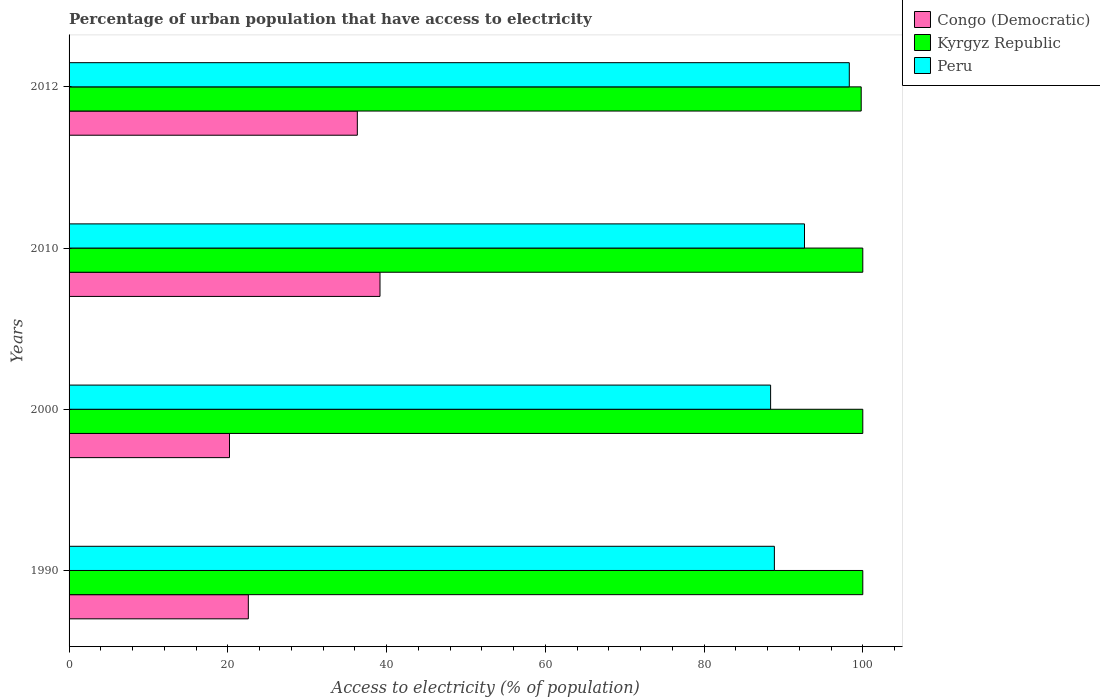How many different coloured bars are there?
Offer a terse response. 3. How many groups of bars are there?
Make the answer very short. 4. How many bars are there on the 4th tick from the top?
Offer a very short reply. 3. What is the label of the 1st group of bars from the top?
Offer a very short reply. 2012. What is the percentage of urban population that have access to electricity in Congo (Democratic) in 2010?
Offer a very short reply. 39.17. Across all years, what is the maximum percentage of urban population that have access to electricity in Congo (Democratic)?
Give a very brief answer. 39.17. Across all years, what is the minimum percentage of urban population that have access to electricity in Congo (Democratic)?
Provide a succinct answer. 20.21. In which year was the percentage of urban population that have access to electricity in Congo (Democratic) maximum?
Give a very brief answer. 2010. What is the total percentage of urban population that have access to electricity in Congo (Democratic) in the graph?
Ensure brevity in your answer.  118.29. What is the difference between the percentage of urban population that have access to electricity in Congo (Democratic) in 1990 and that in 2010?
Provide a succinct answer. -16.59. What is the difference between the percentage of urban population that have access to electricity in Congo (Democratic) in 2000 and the percentage of urban population that have access to electricity in Peru in 2012?
Your response must be concise. -78.09. What is the average percentage of urban population that have access to electricity in Congo (Democratic) per year?
Ensure brevity in your answer.  29.57. In the year 2012, what is the difference between the percentage of urban population that have access to electricity in Peru and percentage of urban population that have access to electricity in Congo (Democratic)?
Your answer should be very brief. 61.98. What is the ratio of the percentage of urban population that have access to electricity in Peru in 1990 to that in 2000?
Provide a short and direct response. 1.01. Is the difference between the percentage of urban population that have access to electricity in Peru in 2010 and 2012 greater than the difference between the percentage of urban population that have access to electricity in Congo (Democratic) in 2010 and 2012?
Your answer should be compact. No. What is the difference between the highest and the lowest percentage of urban population that have access to electricity in Kyrgyz Republic?
Your response must be concise. 0.2. Is the sum of the percentage of urban population that have access to electricity in Congo (Democratic) in 1990 and 2012 greater than the maximum percentage of urban population that have access to electricity in Kyrgyz Republic across all years?
Your response must be concise. No. What does the 1st bar from the top in 2010 represents?
Provide a short and direct response. Peru. What does the 1st bar from the bottom in 2010 represents?
Keep it short and to the point. Congo (Democratic). Is it the case that in every year, the sum of the percentage of urban population that have access to electricity in Peru and percentage of urban population that have access to electricity in Congo (Democratic) is greater than the percentage of urban population that have access to electricity in Kyrgyz Republic?
Offer a very short reply. Yes. Are all the bars in the graph horizontal?
Give a very brief answer. Yes. How many years are there in the graph?
Make the answer very short. 4. What is the difference between two consecutive major ticks on the X-axis?
Keep it short and to the point. 20. Does the graph contain any zero values?
Offer a terse response. No. Does the graph contain grids?
Give a very brief answer. No. Where does the legend appear in the graph?
Give a very brief answer. Top right. How many legend labels are there?
Ensure brevity in your answer.  3. How are the legend labels stacked?
Provide a short and direct response. Vertical. What is the title of the graph?
Keep it short and to the point. Percentage of urban population that have access to electricity. Does "Liechtenstein" appear as one of the legend labels in the graph?
Keep it short and to the point. No. What is the label or title of the X-axis?
Your response must be concise. Access to electricity (% of population). What is the Access to electricity (% of population) in Congo (Democratic) in 1990?
Your answer should be compact. 22.58. What is the Access to electricity (% of population) of Peru in 1990?
Give a very brief answer. 88.86. What is the Access to electricity (% of population) of Congo (Democratic) in 2000?
Keep it short and to the point. 20.21. What is the Access to electricity (% of population) in Peru in 2000?
Offer a terse response. 88.39. What is the Access to electricity (% of population) in Congo (Democratic) in 2010?
Your answer should be very brief. 39.17. What is the Access to electricity (% of population) in Peru in 2010?
Keep it short and to the point. 92.66. What is the Access to electricity (% of population) of Congo (Democratic) in 2012?
Ensure brevity in your answer.  36.32. What is the Access to electricity (% of population) of Kyrgyz Republic in 2012?
Make the answer very short. 99.8. What is the Access to electricity (% of population) in Peru in 2012?
Your answer should be compact. 98.3. Across all years, what is the maximum Access to electricity (% of population) of Congo (Democratic)?
Keep it short and to the point. 39.17. Across all years, what is the maximum Access to electricity (% of population) in Kyrgyz Republic?
Keep it short and to the point. 100. Across all years, what is the maximum Access to electricity (% of population) of Peru?
Offer a very short reply. 98.3. Across all years, what is the minimum Access to electricity (% of population) of Congo (Democratic)?
Offer a very short reply. 20.21. Across all years, what is the minimum Access to electricity (% of population) in Kyrgyz Republic?
Offer a terse response. 99.8. Across all years, what is the minimum Access to electricity (% of population) of Peru?
Give a very brief answer. 88.39. What is the total Access to electricity (% of population) of Congo (Democratic) in the graph?
Offer a terse response. 118.29. What is the total Access to electricity (% of population) in Kyrgyz Republic in the graph?
Give a very brief answer. 399.8. What is the total Access to electricity (% of population) in Peru in the graph?
Offer a very short reply. 368.2. What is the difference between the Access to electricity (% of population) in Congo (Democratic) in 1990 and that in 2000?
Provide a short and direct response. 2.37. What is the difference between the Access to electricity (% of population) in Peru in 1990 and that in 2000?
Your answer should be very brief. 0.47. What is the difference between the Access to electricity (% of population) in Congo (Democratic) in 1990 and that in 2010?
Your response must be concise. -16.59. What is the difference between the Access to electricity (% of population) of Peru in 1990 and that in 2010?
Your answer should be very brief. -3.8. What is the difference between the Access to electricity (% of population) of Congo (Democratic) in 1990 and that in 2012?
Make the answer very short. -13.73. What is the difference between the Access to electricity (% of population) of Kyrgyz Republic in 1990 and that in 2012?
Your answer should be very brief. 0.2. What is the difference between the Access to electricity (% of population) in Peru in 1990 and that in 2012?
Make the answer very short. -9.44. What is the difference between the Access to electricity (% of population) of Congo (Democratic) in 2000 and that in 2010?
Your answer should be compact. -18.96. What is the difference between the Access to electricity (% of population) in Kyrgyz Republic in 2000 and that in 2010?
Offer a terse response. 0. What is the difference between the Access to electricity (% of population) of Peru in 2000 and that in 2010?
Your response must be concise. -4.27. What is the difference between the Access to electricity (% of population) in Congo (Democratic) in 2000 and that in 2012?
Provide a short and direct response. -16.11. What is the difference between the Access to electricity (% of population) in Peru in 2000 and that in 2012?
Your answer should be very brief. -9.91. What is the difference between the Access to electricity (% of population) of Congo (Democratic) in 2010 and that in 2012?
Make the answer very short. 2.86. What is the difference between the Access to electricity (% of population) in Kyrgyz Republic in 2010 and that in 2012?
Offer a terse response. 0.2. What is the difference between the Access to electricity (% of population) in Peru in 2010 and that in 2012?
Make the answer very short. -5.64. What is the difference between the Access to electricity (% of population) of Congo (Democratic) in 1990 and the Access to electricity (% of population) of Kyrgyz Republic in 2000?
Offer a very short reply. -77.42. What is the difference between the Access to electricity (% of population) in Congo (Democratic) in 1990 and the Access to electricity (% of population) in Peru in 2000?
Provide a short and direct response. -65.8. What is the difference between the Access to electricity (% of population) of Kyrgyz Republic in 1990 and the Access to electricity (% of population) of Peru in 2000?
Keep it short and to the point. 11.61. What is the difference between the Access to electricity (% of population) in Congo (Democratic) in 1990 and the Access to electricity (% of population) in Kyrgyz Republic in 2010?
Offer a terse response. -77.42. What is the difference between the Access to electricity (% of population) of Congo (Democratic) in 1990 and the Access to electricity (% of population) of Peru in 2010?
Make the answer very short. -70.07. What is the difference between the Access to electricity (% of population) in Kyrgyz Republic in 1990 and the Access to electricity (% of population) in Peru in 2010?
Give a very brief answer. 7.34. What is the difference between the Access to electricity (% of population) in Congo (Democratic) in 1990 and the Access to electricity (% of population) in Kyrgyz Republic in 2012?
Keep it short and to the point. -77.22. What is the difference between the Access to electricity (% of population) in Congo (Democratic) in 1990 and the Access to electricity (% of population) in Peru in 2012?
Your answer should be compact. -75.72. What is the difference between the Access to electricity (% of population) in Kyrgyz Republic in 1990 and the Access to electricity (% of population) in Peru in 2012?
Give a very brief answer. 1.7. What is the difference between the Access to electricity (% of population) of Congo (Democratic) in 2000 and the Access to electricity (% of population) of Kyrgyz Republic in 2010?
Offer a terse response. -79.79. What is the difference between the Access to electricity (% of population) of Congo (Democratic) in 2000 and the Access to electricity (% of population) of Peru in 2010?
Keep it short and to the point. -72.44. What is the difference between the Access to electricity (% of population) of Kyrgyz Republic in 2000 and the Access to electricity (% of population) of Peru in 2010?
Make the answer very short. 7.34. What is the difference between the Access to electricity (% of population) in Congo (Democratic) in 2000 and the Access to electricity (% of population) in Kyrgyz Republic in 2012?
Offer a terse response. -79.59. What is the difference between the Access to electricity (% of population) of Congo (Democratic) in 2000 and the Access to electricity (% of population) of Peru in 2012?
Keep it short and to the point. -78.09. What is the difference between the Access to electricity (% of population) in Kyrgyz Republic in 2000 and the Access to electricity (% of population) in Peru in 2012?
Provide a short and direct response. 1.7. What is the difference between the Access to electricity (% of population) of Congo (Democratic) in 2010 and the Access to electricity (% of population) of Kyrgyz Republic in 2012?
Your answer should be compact. -60.63. What is the difference between the Access to electricity (% of population) in Congo (Democratic) in 2010 and the Access to electricity (% of population) in Peru in 2012?
Offer a terse response. -59.13. What is the average Access to electricity (% of population) in Congo (Democratic) per year?
Ensure brevity in your answer.  29.57. What is the average Access to electricity (% of population) of Kyrgyz Republic per year?
Offer a terse response. 99.95. What is the average Access to electricity (% of population) in Peru per year?
Your response must be concise. 92.05. In the year 1990, what is the difference between the Access to electricity (% of population) of Congo (Democratic) and Access to electricity (% of population) of Kyrgyz Republic?
Your response must be concise. -77.42. In the year 1990, what is the difference between the Access to electricity (% of population) of Congo (Democratic) and Access to electricity (% of population) of Peru?
Provide a succinct answer. -66.28. In the year 1990, what is the difference between the Access to electricity (% of population) in Kyrgyz Republic and Access to electricity (% of population) in Peru?
Your answer should be very brief. 11.14. In the year 2000, what is the difference between the Access to electricity (% of population) in Congo (Democratic) and Access to electricity (% of population) in Kyrgyz Republic?
Offer a terse response. -79.79. In the year 2000, what is the difference between the Access to electricity (% of population) in Congo (Democratic) and Access to electricity (% of population) in Peru?
Make the answer very short. -68.17. In the year 2000, what is the difference between the Access to electricity (% of population) of Kyrgyz Republic and Access to electricity (% of population) of Peru?
Offer a very short reply. 11.61. In the year 2010, what is the difference between the Access to electricity (% of population) of Congo (Democratic) and Access to electricity (% of population) of Kyrgyz Republic?
Keep it short and to the point. -60.83. In the year 2010, what is the difference between the Access to electricity (% of population) of Congo (Democratic) and Access to electricity (% of population) of Peru?
Provide a succinct answer. -53.48. In the year 2010, what is the difference between the Access to electricity (% of population) of Kyrgyz Republic and Access to electricity (% of population) of Peru?
Ensure brevity in your answer.  7.34. In the year 2012, what is the difference between the Access to electricity (% of population) of Congo (Democratic) and Access to electricity (% of population) of Kyrgyz Republic?
Provide a succinct answer. -63.48. In the year 2012, what is the difference between the Access to electricity (% of population) of Congo (Democratic) and Access to electricity (% of population) of Peru?
Provide a short and direct response. -61.98. In the year 2012, what is the difference between the Access to electricity (% of population) of Kyrgyz Republic and Access to electricity (% of population) of Peru?
Provide a short and direct response. 1.5. What is the ratio of the Access to electricity (% of population) of Congo (Democratic) in 1990 to that in 2000?
Provide a short and direct response. 1.12. What is the ratio of the Access to electricity (% of population) of Peru in 1990 to that in 2000?
Ensure brevity in your answer.  1.01. What is the ratio of the Access to electricity (% of population) in Congo (Democratic) in 1990 to that in 2010?
Provide a succinct answer. 0.58. What is the ratio of the Access to electricity (% of population) in Congo (Democratic) in 1990 to that in 2012?
Give a very brief answer. 0.62. What is the ratio of the Access to electricity (% of population) of Peru in 1990 to that in 2012?
Give a very brief answer. 0.9. What is the ratio of the Access to electricity (% of population) of Congo (Democratic) in 2000 to that in 2010?
Provide a succinct answer. 0.52. What is the ratio of the Access to electricity (% of population) of Peru in 2000 to that in 2010?
Offer a very short reply. 0.95. What is the ratio of the Access to electricity (% of population) in Congo (Democratic) in 2000 to that in 2012?
Provide a short and direct response. 0.56. What is the ratio of the Access to electricity (% of population) in Peru in 2000 to that in 2012?
Your response must be concise. 0.9. What is the ratio of the Access to electricity (% of population) in Congo (Democratic) in 2010 to that in 2012?
Your answer should be very brief. 1.08. What is the ratio of the Access to electricity (% of population) in Peru in 2010 to that in 2012?
Keep it short and to the point. 0.94. What is the difference between the highest and the second highest Access to electricity (% of population) of Congo (Democratic)?
Provide a succinct answer. 2.86. What is the difference between the highest and the second highest Access to electricity (% of population) in Kyrgyz Republic?
Offer a terse response. 0. What is the difference between the highest and the second highest Access to electricity (% of population) of Peru?
Offer a very short reply. 5.64. What is the difference between the highest and the lowest Access to electricity (% of population) in Congo (Democratic)?
Offer a terse response. 18.96. What is the difference between the highest and the lowest Access to electricity (% of population) in Kyrgyz Republic?
Give a very brief answer. 0.2. What is the difference between the highest and the lowest Access to electricity (% of population) of Peru?
Keep it short and to the point. 9.91. 